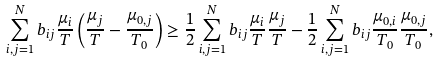Convert formula to latex. <formula><loc_0><loc_0><loc_500><loc_500>\sum _ { i , j = 1 } ^ { N } b _ { i j } \frac { \mu _ { i } } { T } \left ( \frac { \mu _ { j } } { T } - \frac { \mu _ { 0 , j } } { T _ { 0 } } \right ) & \geq \frac { 1 } { 2 } \sum _ { i , j = 1 } ^ { N } b _ { i j } \frac { \mu _ { i } } { T } \frac { \mu _ { j } } { T } - \frac { 1 } { 2 } \sum _ { i , j = 1 } ^ { N } b _ { i j } \frac { \mu _ { 0 , i } } { T _ { 0 } } \frac { \mu _ { 0 , j } } { T _ { 0 } } ,</formula> 